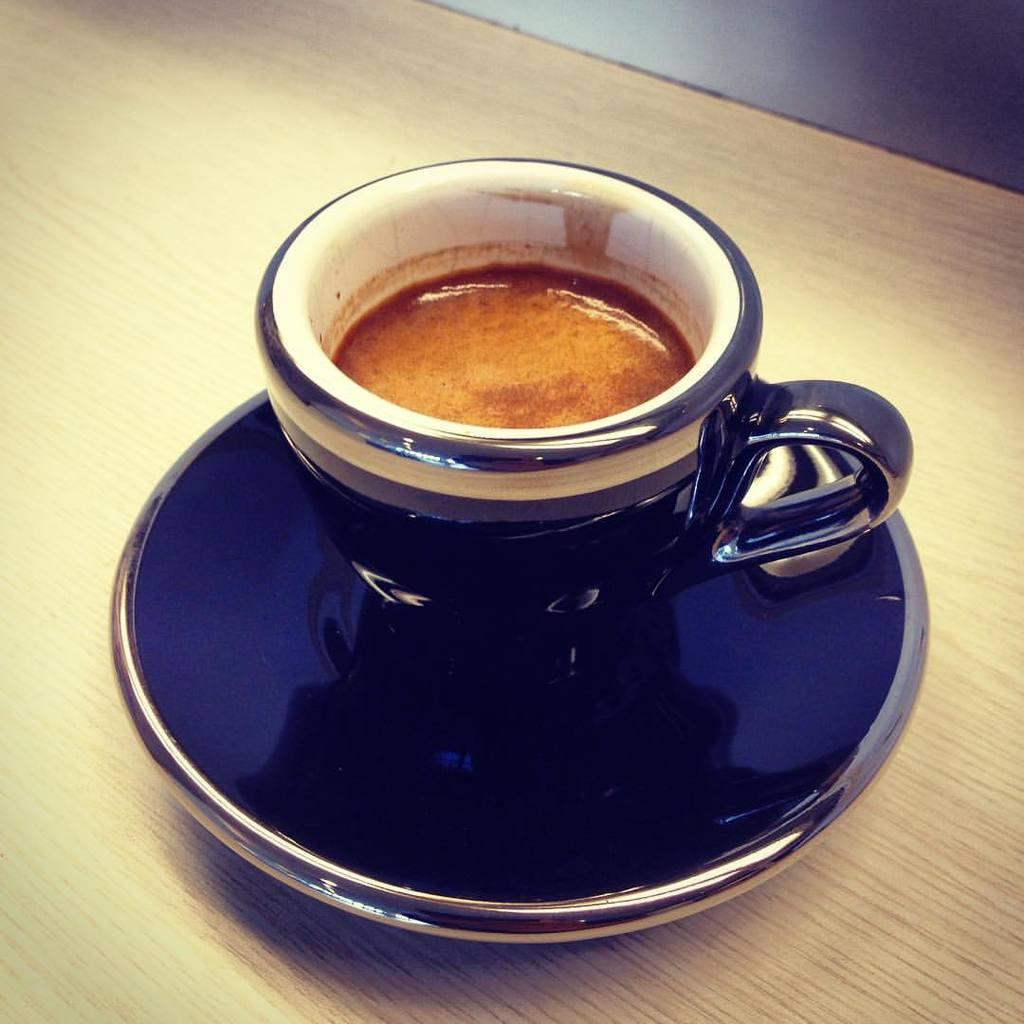What is in the cup that is visible in the image? There is a cup of coffee in the image. What is the cup of coffee resting on? The cup of coffee is on a saucer. What type of bread can be seen in the image? There is no bread present in the image; it only features a cup of coffee on a saucer. 